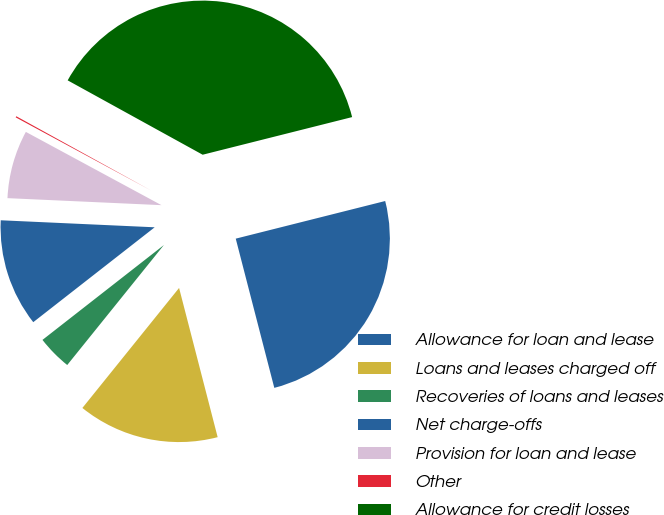<chart> <loc_0><loc_0><loc_500><loc_500><pie_chart><fcel>Allowance for loan and lease<fcel>Loans and leases charged off<fcel>Recoveries of loans and leases<fcel>Net charge-offs<fcel>Provision for loan and lease<fcel>Other<fcel>Allowance for credit losses<nl><fcel>24.9%<fcel>14.82%<fcel>3.65%<fcel>11.28%<fcel>7.16%<fcel>0.13%<fcel>38.06%<nl></chart> 